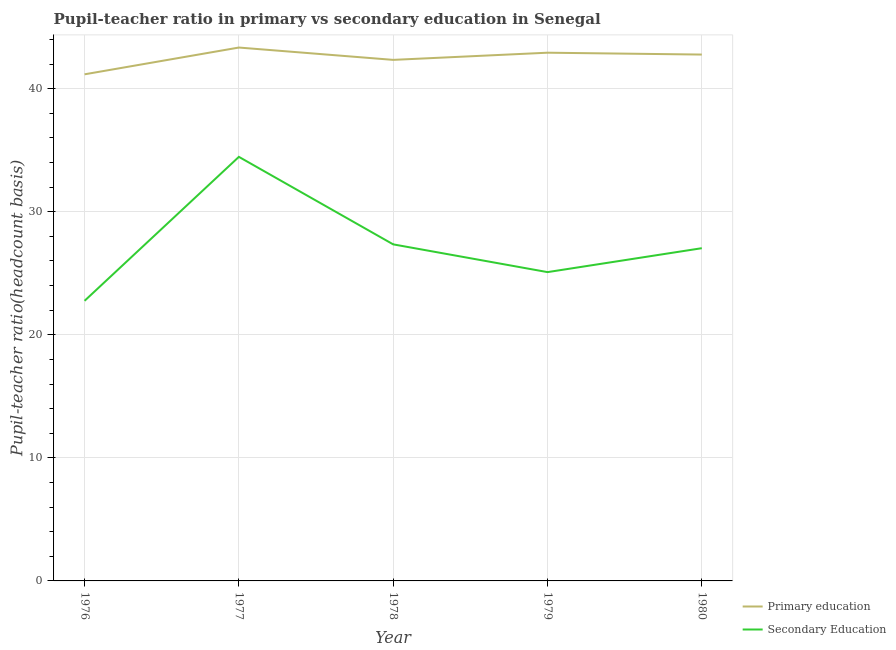Does the line corresponding to pupil teacher ratio on secondary education intersect with the line corresponding to pupil-teacher ratio in primary education?
Offer a terse response. No. Is the number of lines equal to the number of legend labels?
Make the answer very short. Yes. What is the pupil teacher ratio on secondary education in 1977?
Your response must be concise. 34.46. Across all years, what is the maximum pupil teacher ratio on secondary education?
Offer a terse response. 34.46. Across all years, what is the minimum pupil-teacher ratio in primary education?
Provide a succinct answer. 41.17. In which year was the pupil teacher ratio on secondary education maximum?
Provide a succinct answer. 1977. In which year was the pupil teacher ratio on secondary education minimum?
Keep it short and to the point. 1976. What is the total pupil-teacher ratio in primary education in the graph?
Offer a very short reply. 212.54. What is the difference between the pupil teacher ratio on secondary education in 1976 and that in 1977?
Offer a very short reply. -11.7. What is the difference between the pupil teacher ratio on secondary education in 1978 and the pupil-teacher ratio in primary education in 1977?
Your answer should be very brief. -15.99. What is the average pupil teacher ratio on secondary education per year?
Offer a very short reply. 27.34. In the year 1976, what is the difference between the pupil teacher ratio on secondary education and pupil-teacher ratio in primary education?
Give a very brief answer. -18.41. In how many years, is the pupil-teacher ratio in primary education greater than 34?
Provide a succinct answer. 5. What is the ratio of the pupil-teacher ratio in primary education in 1976 to that in 1980?
Your answer should be compact. 0.96. Is the pupil-teacher ratio in primary education in 1976 less than that in 1978?
Your answer should be compact. Yes. What is the difference between the highest and the second highest pupil teacher ratio on secondary education?
Your response must be concise. 7.11. What is the difference between the highest and the lowest pupil-teacher ratio in primary education?
Provide a short and direct response. 2.18. In how many years, is the pupil-teacher ratio in primary education greater than the average pupil-teacher ratio in primary education taken over all years?
Keep it short and to the point. 3. How many years are there in the graph?
Provide a succinct answer. 5. What is the difference between two consecutive major ticks on the Y-axis?
Your answer should be very brief. 10. How many legend labels are there?
Your response must be concise. 2. How are the legend labels stacked?
Your answer should be very brief. Vertical. What is the title of the graph?
Your answer should be compact. Pupil-teacher ratio in primary vs secondary education in Senegal. What is the label or title of the Y-axis?
Offer a terse response. Pupil-teacher ratio(headcount basis). What is the Pupil-teacher ratio(headcount basis) in Primary education in 1976?
Your answer should be very brief. 41.17. What is the Pupil-teacher ratio(headcount basis) of Secondary Education in 1976?
Offer a terse response. 22.76. What is the Pupil-teacher ratio(headcount basis) in Primary education in 1977?
Provide a short and direct response. 43.34. What is the Pupil-teacher ratio(headcount basis) of Secondary Education in 1977?
Give a very brief answer. 34.46. What is the Pupil-teacher ratio(headcount basis) in Primary education in 1978?
Provide a short and direct response. 42.34. What is the Pupil-teacher ratio(headcount basis) of Secondary Education in 1978?
Provide a short and direct response. 27.35. What is the Pupil-teacher ratio(headcount basis) in Primary education in 1979?
Your answer should be compact. 42.92. What is the Pupil-teacher ratio(headcount basis) of Secondary Education in 1979?
Provide a succinct answer. 25.09. What is the Pupil-teacher ratio(headcount basis) of Primary education in 1980?
Make the answer very short. 42.77. What is the Pupil-teacher ratio(headcount basis) of Secondary Education in 1980?
Offer a very short reply. 27.04. Across all years, what is the maximum Pupil-teacher ratio(headcount basis) of Primary education?
Your answer should be compact. 43.34. Across all years, what is the maximum Pupil-teacher ratio(headcount basis) of Secondary Education?
Give a very brief answer. 34.46. Across all years, what is the minimum Pupil-teacher ratio(headcount basis) in Primary education?
Provide a short and direct response. 41.17. Across all years, what is the minimum Pupil-teacher ratio(headcount basis) in Secondary Education?
Make the answer very short. 22.76. What is the total Pupil-teacher ratio(headcount basis) in Primary education in the graph?
Keep it short and to the point. 212.54. What is the total Pupil-teacher ratio(headcount basis) in Secondary Education in the graph?
Your answer should be compact. 136.7. What is the difference between the Pupil-teacher ratio(headcount basis) of Primary education in 1976 and that in 1977?
Make the answer very short. -2.18. What is the difference between the Pupil-teacher ratio(headcount basis) of Secondary Education in 1976 and that in 1977?
Give a very brief answer. -11.7. What is the difference between the Pupil-teacher ratio(headcount basis) in Primary education in 1976 and that in 1978?
Your answer should be compact. -1.17. What is the difference between the Pupil-teacher ratio(headcount basis) of Secondary Education in 1976 and that in 1978?
Your response must be concise. -4.59. What is the difference between the Pupil-teacher ratio(headcount basis) of Primary education in 1976 and that in 1979?
Offer a terse response. -1.76. What is the difference between the Pupil-teacher ratio(headcount basis) of Secondary Education in 1976 and that in 1979?
Give a very brief answer. -2.33. What is the difference between the Pupil-teacher ratio(headcount basis) of Primary education in 1976 and that in 1980?
Keep it short and to the point. -1.6. What is the difference between the Pupil-teacher ratio(headcount basis) of Secondary Education in 1976 and that in 1980?
Keep it short and to the point. -4.28. What is the difference between the Pupil-teacher ratio(headcount basis) of Primary education in 1977 and that in 1978?
Your answer should be very brief. 1. What is the difference between the Pupil-teacher ratio(headcount basis) in Secondary Education in 1977 and that in 1978?
Keep it short and to the point. 7.11. What is the difference between the Pupil-teacher ratio(headcount basis) in Primary education in 1977 and that in 1979?
Ensure brevity in your answer.  0.42. What is the difference between the Pupil-teacher ratio(headcount basis) in Secondary Education in 1977 and that in 1979?
Your answer should be compact. 9.37. What is the difference between the Pupil-teacher ratio(headcount basis) of Primary education in 1977 and that in 1980?
Your answer should be very brief. 0.57. What is the difference between the Pupil-teacher ratio(headcount basis) of Secondary Education in 1977 and that in 1980?
Ensure brevity in your answer.  7.42. What is the difference between the Pupil-teacher ratio(headcount basis) of Primary education in 1978 and that in 1979?
Provide a succinct answer. -0.58. What is the difference between the Pupil-teacher ratio(headcount basis) in Secondary Education in 1978 and that in 1979?
Offer a very short reply. 2.25. What is the difference between the Pupil-teacher ratio(headcount basis) in Primary education in 1978 and that in 1980?
Your answer should be compact. -0.43. What is the difference between the Pupil-teacher ratio(headcount basis) in Secondary Education in 1978 and that in 1980?
Your response must be concise. 0.31. What is the difference between the Pupil-teacher ratio(headcount basis) of Primary education in 1979 and that in 1980?
Provide a succinct answer. 0.15. What is the difference between the Pupil-teacher ratio(headcount basis) in Secondary Education in 1979 and that in 1980?
Offer a very short reply. -1.94. What is the difference between the Pupil-teacher ratio(headcount basis) of Primary education in 1976 and the Pupil-teacher ratio(headcount basis) of Secondary Education in 1977?
Your answer should be compact. 6.71. What is the difference between the Pupil-teacher ratio(headcount basis) in Primary education in 1976 and the Pupil-teacher ratio(headcount basis) in Secondary Education in 1978?
Provide a succinct answer. 13.82. What is the difference between the Pupil-teacher ratio(headcount basis) of Primary education in 1976 and the Pupil-teacher ratio(headcount basis) of Secondary Education in 1979?
Your answer should be compact. 16.07. What is the difference between the Pupil-teacher ratio(headcount basis) of Primary education in 1976 and the Pupil-teacher ratio(headcount basis) of Secondary Education in 1980?
Provide a succinct answer. 14.13. What is the difference between the Pupil-teacher ratio(headcount basis) in Primary education in 1977 and the Pupil-teacher ratio(headcount basis) in Secondary Education in 1978?
Ensure brevity in your answer.  15.99. What is the difference between the Pupil-teacher ratio(headcount basis) in Primary education in 1977 and the Pupil-teacher ratio(headcount basis) in Secondary Education in 1979?
Your answer should be compact. 18.25. What is the difference between the Pupil-teacher ratio(headcount basis) in Primary education in 1977 and the Pupil-teacher ratio(headcount basis) in Secondary Education in 1980?
Ensure brevity in your answer.  16.3. What is the difference between the Pupil-teacher ratio(headcount basis) in Primary education in 1978 and the Pupil-teacher ratio(headcount basis) in Secondary Education in 1979?
Make the answer very short. 17.25. What is the difference between the Pupil-teacher ratio(headcount basis) of Primary education in 1978 and the Pupil-teacher ratio(headcount basis) of Secondary Education in 1980?
Ensure brevity in your answer.  15.3. What is the difference between the Pupil-teacher ratio(headcount basis) in Primary education in 1979 and the Pupil-teacher ratio(headcount basis) in Secondary Education in 1980?
Provide a succinct answer. 15.88. What is the average Pupil-teacher ratio(headcount basis) in Primary education per year?
Make the answer very short. 42.51. What is the average Pupil-teacher ratio(headcount basis) in Secondary Education per year?
Provide a short and direct response. 27.34. In the year 1976, what is the difference between the Pupil-teacher ratio(headcount basis) in Primary education and Pupil-teacher ratio(headcount basis) in Secondary Education?
Your answer should be very brief. 18.41. In the year 1977, what is the difference between the Pupil-teacher ratio(headcount basis) of Primary education and Pupil-teacher ratio(headcount basis) of Secondary Education?
Give a very brief answer. 8.88. In the year 1978, what is the difference between the Pupil-teacher ratio(headcount basis) of Primary education and Pupil-teacher ratio(headcount basis) of Secondary Education?
Your answer should be compact. 14.99. In the year 1979, what is the difference between the Pupil-teacher ratio(headcount basis) of Primary education and Pupil-teacher ratio(headcount basis) of Secondary Education?
Your answer should be compact. 17.83. In the year 1980, what is the difference between the Pupil-teacher ratio(headcount basis) in Primary education and Pupil-teacher ratio(headcount basis) in Secondary Education?
Offer a very short reply. 15.73. What is the ratio of the Pupil-teacher ratio(headcount basis) of Primary education in 1976 to that in 1977?
Your answer should be very brief. 0.95. What is the ratio of the Pupil-teacher ratio(headcount basis) of Secondary Education in 1976 to that in 1977?
Give a very brief answer. 0.66. What is the ratio of the Pupil-teacher ratio(headcount basis) in Primary education in 1976 to that in 1978?
Offer a terse response. 0.97. What is the ratio of the Pupil-teacher ratio(headcount basis) in Secondary Education in 1976 to that in 1978?
Give a very brief answer. 0.83. What is the ratio of the Pupil-teacher ratio(headcount basis) of Primary education in 1976 to that in 1979?
Provide a short and direct response. 0.96. What is the ratio of the Pupil-teacher ratio(headcount basis) in Secondary Education in 1976 to that in 1979?
Offer a very short reply. 0.91. What is the ratio of the Pupil-teacher ratio(headcount basis) of Primary education in 1976 to that in 1980?
Make the answer very short. 0.96. What is the ratio of the Pupil-teacher ratio(headcount basis) in Secondary Education in 1976 to that in 1980?
Offer a terse response. 0.84. What is the ratio of the Pupil-teacher ratio(headcount basis) in Primary education in 1977 to that in 1978?
Provide a succinct answer. 1.02. What is the ratio of the Pupil-teacher ratio(headcount basis) in Secondary Education in 1977 to that in 1978?
Provide a short and direct response. 1.26. What is the ratio of the Pupil-teacher ratio(headcount basis) in Primary education in 1977 to that in 1979?
Your answer should be compact. 1.01. What is the ratio of the Pupil-teacher ratio(headcount basis) of Secondary Education in 1977 to that in 1979?
Make the answer very short. 1.37. What is the ratio of the Pupil-teacher ratio(headcount basis) in Primary education in 1977 to that in 1980?
Offer a very short reply. 1.01. What is the ratio of the Pupil-teacher ratio(headcount basis) in Secondary Education in 1977 to that in 1980?
Provide a succinct answer. 1.27. What is the ratio of the Pupil-teacher ratio(headcount basis) in Primary education in 1978 to that in 1979?
Offer a very short reply. 0.99. What is the ratio of the Pupil-teacher ratio(headcount basis) in Secondary Education in 1978 to that in 1979?
Provide a short and direct response. 1.09. What is the ratio of the Pupil-teacher ratio(headcount basis) of Secondary Education in 1978 to that in 1980?
Ensure brevity in your answer.  1.01. What is the ratio of the Pupil-teacher ratio(headcount basis) of Primary education in 1979 to that in 1980?
Your response must be concise. 1. What is the ratio of the Pupil-teacher ratio(headcount basis) in Secondary Education in 1979 to that in 1980?
Offer a terse response. 0.93. What is the difference between the highest and the second highest Pupil-teacher ratio(headcount basis) in Primary education?
Your answer should be compact. 0.42. What is the difference between the highest and the second highest Pupil-teacher ratio(headcount basis) in Secondary Education?
Make the answer very short. 7.11. What is the difference between the highest and the lowest Pupil-teacher ratio(headcount basis) in Primary education?
Provide a short and direct response. 2.18. What is the difference between the highest and the lowest Pupil-teacher ratio(headcount basis) of Secondary Education?
Your answer should be compact. 11.7. 